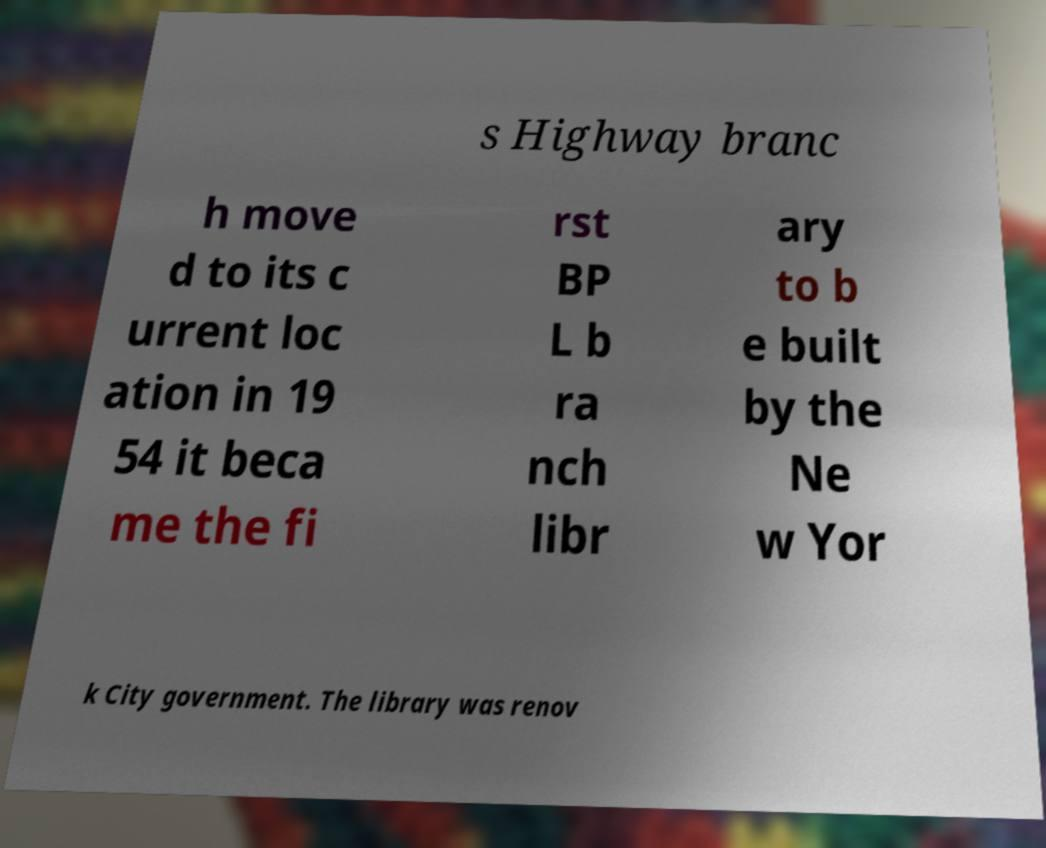Please identify and transcribe the text found in this image. s Highway branc h move d to its c urrent loc ation in 19 54 it beca me the fi rst BP L b ra nch libr ary to b e built by the Ne w Yor k City government. The library was renov 